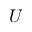Convert formula to latex. <formula><loc_0><loc_0><loc_500><loc_500>U</formula> 